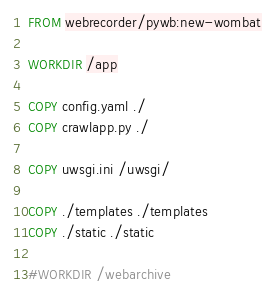<code> <loc_0><loc_0><loc_500><loc_500><_Dockerfile_>FROM webrecorder/pywb:new-wombat

WORKDIR /app

COPY config.yaml ./
COPY crawlapp.py ./

COPY uwsgi.ini /uwsgi/

COPY ./templates ./templates
COPY ./static ./static

#WORKDIR /webarchive

</code> 